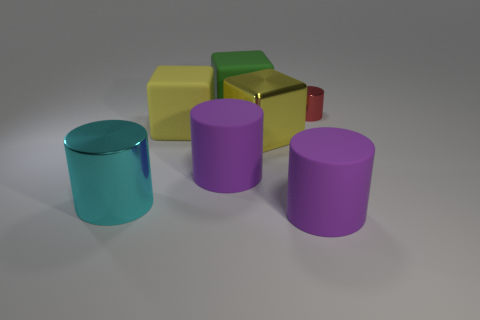There is a purple object to the left of the purple rubber cylinder that is on the right side of the big purple matte object that is behind the large cyan metal cylinder; what size is it?
Ensure brevity in your answer.  Large. What size is the red object that is the same shape as the cyan object?
Your answer should be very brief. Small. How many small red things are on the right side of the large yellow metal block?
Keep it short and to the point. 1. Do the cylinder behind the yellow metallic cube and the big shiny block have the same color?
Ensure brevity in your answer.  No. What number of green things are tiny metal cylinders or rubber things?
Your answer should be compact. 1. The metal cylinder that is on the right side of the large thing to the left of the yellow rubber thing is what color?
Offer a terse response. Red. What material is the other cube that is the same color as the big metal block?
Make the answer very short. Rubber. What is the color of the rubber block that is behind the tiny thing?
Give a very brief answer. Green. There is a purple rubber object left of the green rubber object; is its size the same as the cyan cylinder?
Give a very brief answer. Yes. There is a thing that is the same color as the shiny block; what size is it?
Give a very brief answer. Large. 